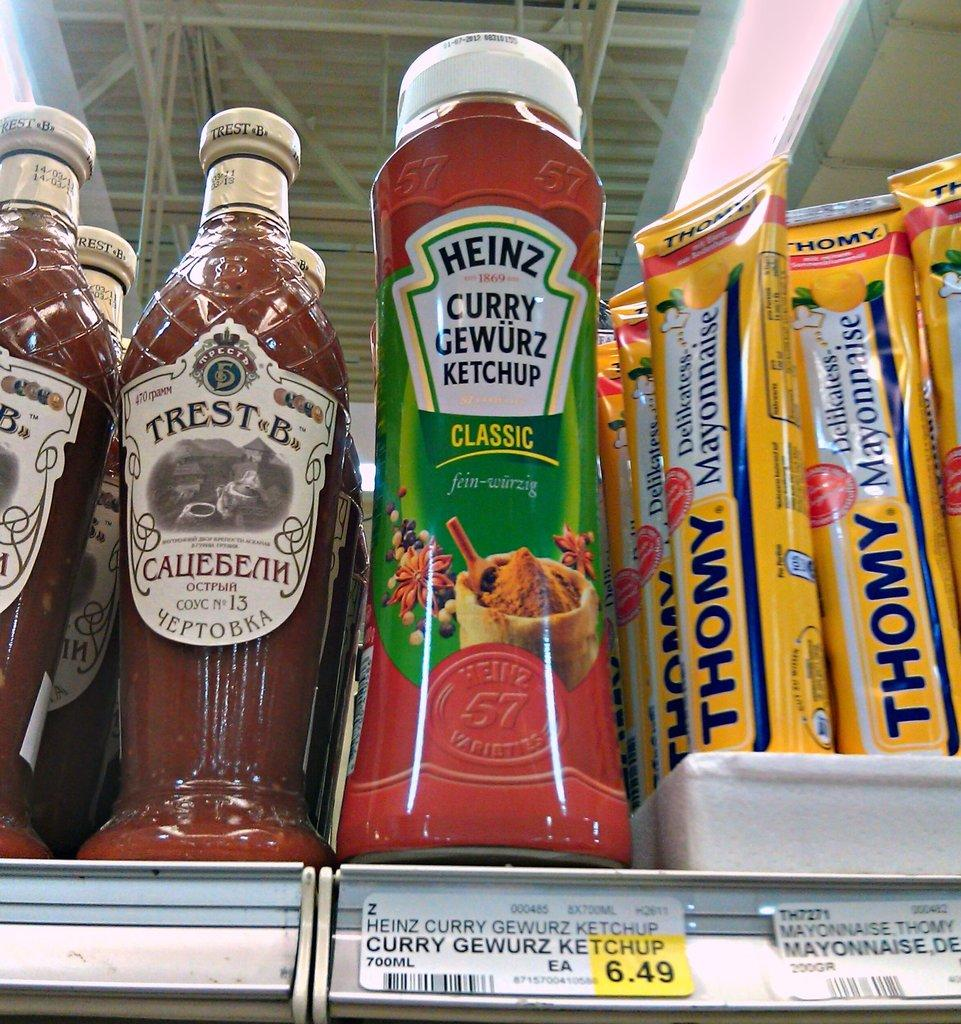<image>
Summarize the visual content of the image. A bottle of ketchup is on a shelf next to other products. 